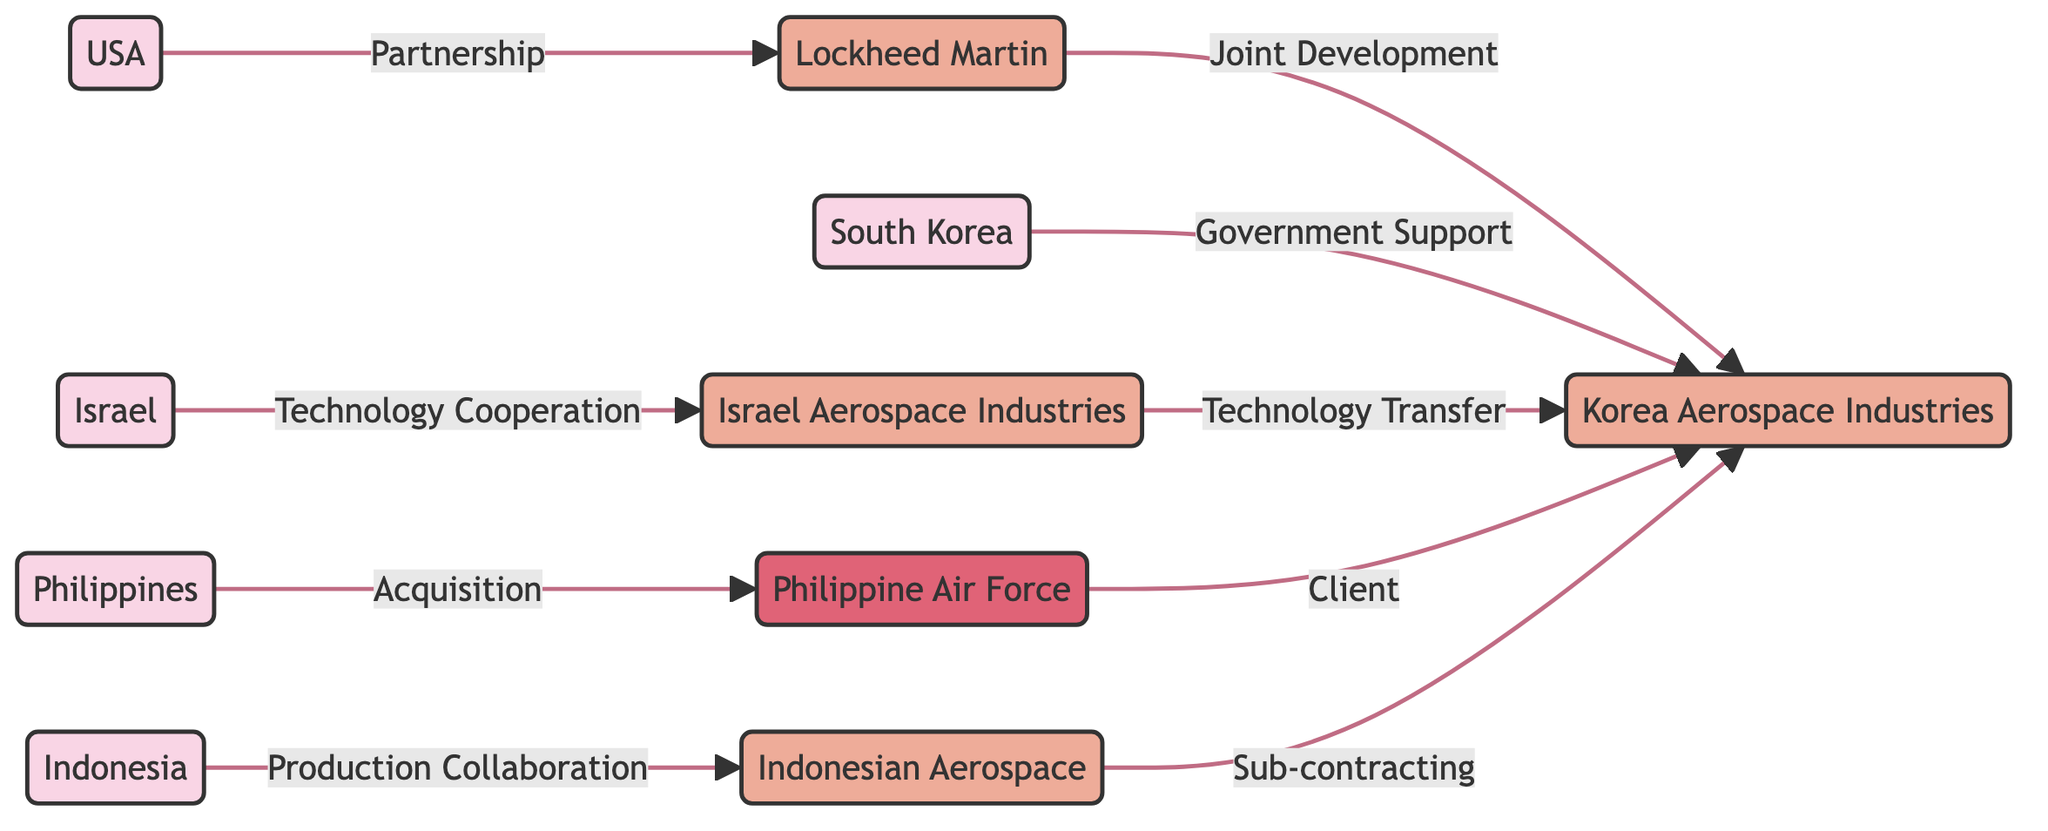What's the total number of nodes in the diagram? Counting each unique entity in the nodes section, there are 10 distinct nodes representing countries and companies involved in the T-50 aircraft project.
Answer: 10 Which entity has a direct partnership with the USA? Looking at the edges, the edge labeled "Partnership" connects the USA to Lockheed Martin, indicating the direct relationship.
Answer: Lockheed Martin What type of support does South Korea provide to Korea Aerospace Industries? The edge labeled "Government Support" indicates the type of relationship from South Korea to Korea Aerospace Industries, showing this specific type of assistance.
Answer: Government Support How many entities are directly connected to Korea Aerospace Industries? By examining the edges, Korea Aerospace Industries has three direct connections: one from Lockheed Martin, one from South Korea, and one from Philippine Air Force, as well as two from Israeli entities. This totals five direct connections.
Answer: 5 Which company collaborates on production with Indonesia? The edge labeled "Production Collaboration" shows a direct connection from Indonesia to Indonesian Aerospace, indicating the company involved in this partnership.
Answer: Indonesian Aerospace What is the relationship between Israel and Korea Aerospace Industries? Tracing the relationship, Israel connects to Israel Aerospace Industries through "Technology Cooperation", which then transfers technology to Korea Aerospace Industries through "Technology Transfer", indicating a dual pathway relationship.
Answer: Technology Transfer Who are the clients of Korea Aerospace Industries? By following the directed edges, the Philippine Air Force is identified as a client for Korea Aerospace Industries, as shown by the labeled connection "Client".
Answer: Philippine Air Force What kind of collaboration exists between Indonesian Aerospace and Korea Aerospace Industries? The diagram specifies that the relationship is one of "Sub-contracting" between Indonesian Aerospace and Korea Aerospace Industries, indicating a form of partnership regarding production or services.
Answer: Sub-contracting What collaboration type exists between Lockheed Martin and Korea Aerospace Industries? The connection between Lockheed Martin and Korea Aerospace Industries is labeled "Joint Development", indicating the specific nature of their relationship.
Answer: Joint Development 